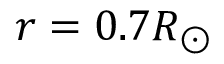<formula> <loc_0><loc_0><loc_500><loc_500>r = 0 . 7 R _ { \odot }</formula> 